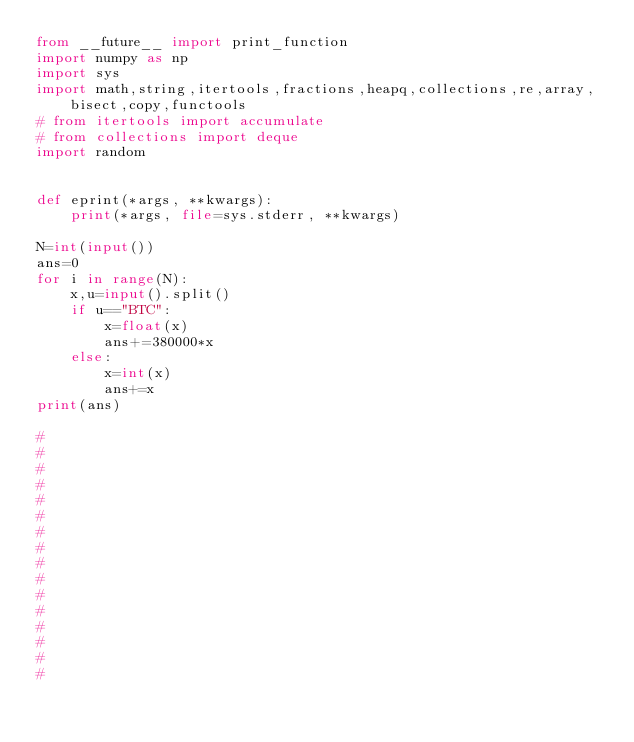Convert code to text. <code><loc_0><loc_0><loc_500><loc_500><_Python_>from __future__ import print_function
import numpy as np
import sys
import math,string,itertools,fractions,heapq,collections,re,array,bisect,copy,functools
# from itertools import accumulate
# from collections import deque
import random


def eprint(*args, **kwargs):
    print(*args, file=sys.stderr, **kwargs)

N=int(input())
ans=0
for i in range(N):
    x,u=input().split()
    if u=="BTC":
        x=float(x)
        ans+=380000*x
    else:
        x=int(x)
        ans+=x
print(ans)

#
#
#
#
#
#
#
#
#
#
#
#
#
#
#
#
</code> 